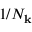<formula> <loc_0><loc_0><loc_500><loc_500>1 / N _ { k }</formula> 